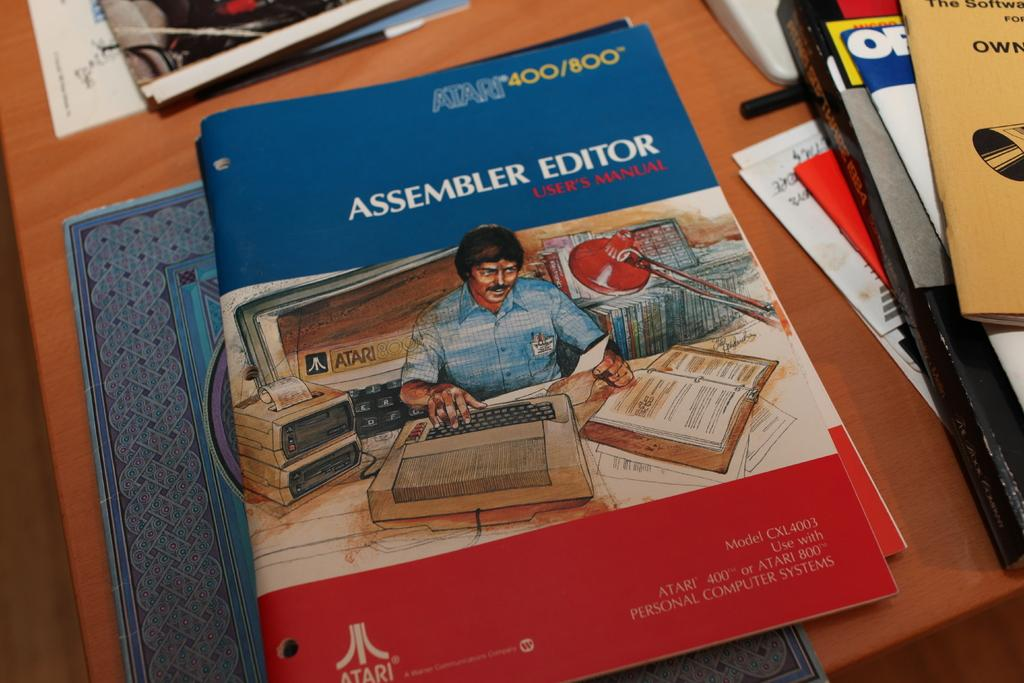Provide a one-sentence caption for the provided image. A book with a cartoon on its cover is titled Assembler Editor. 